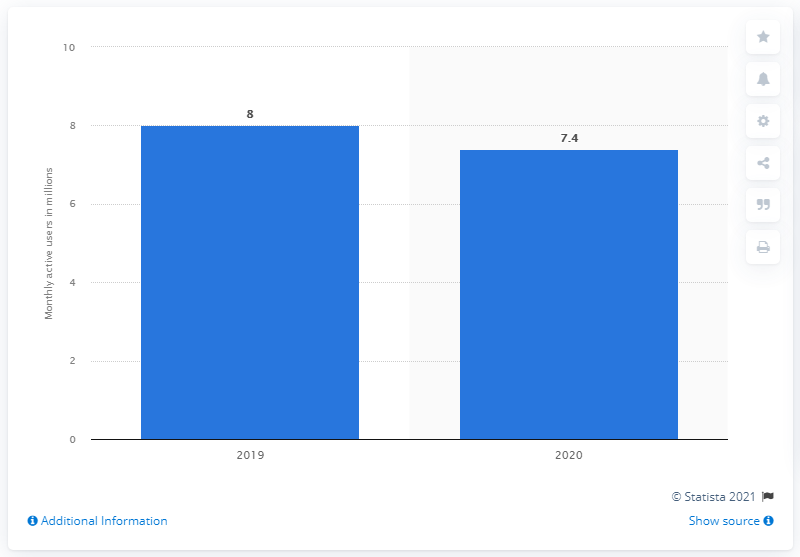List a handful of essential elements in this visual. In 2020, SciPlay had approximately 7.4 active users. 